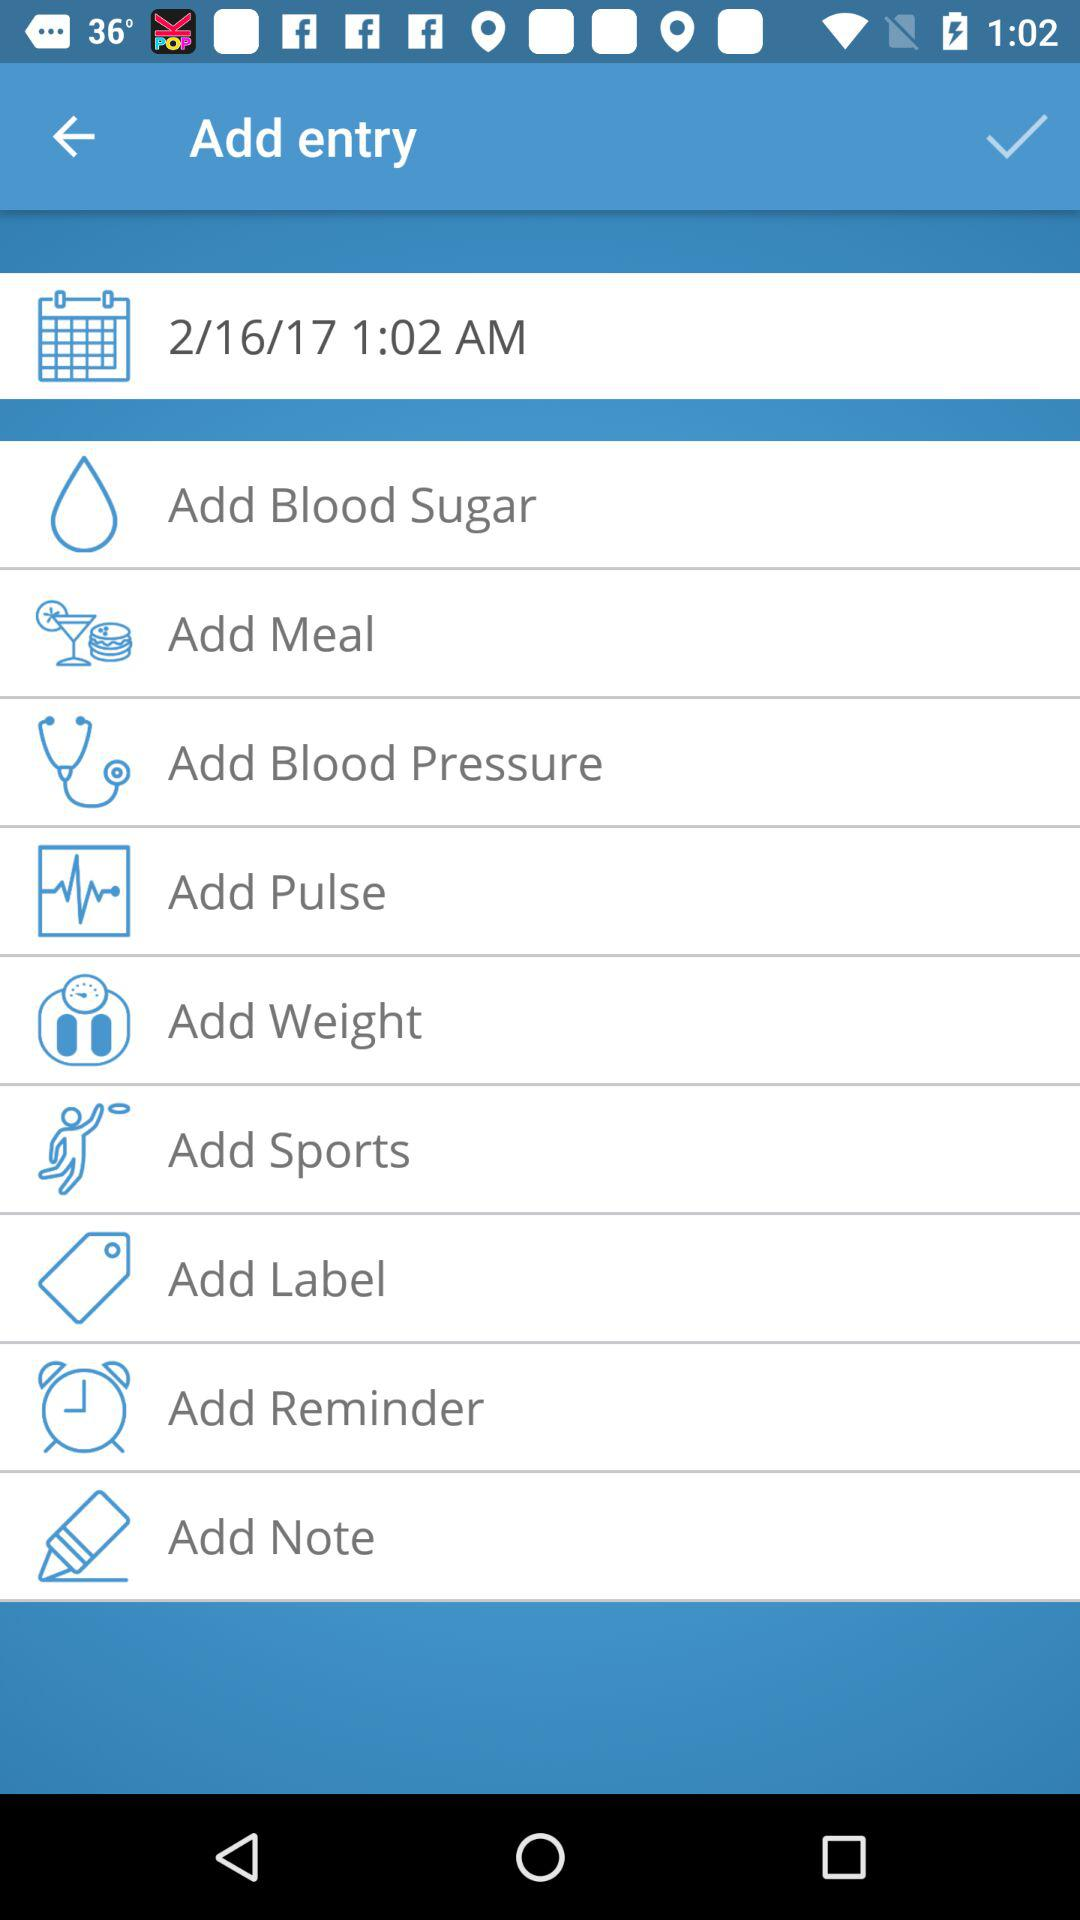What is the mentioned date and time? The mentioned date is February 16, 2017 and the time is 1:02 a.m. 